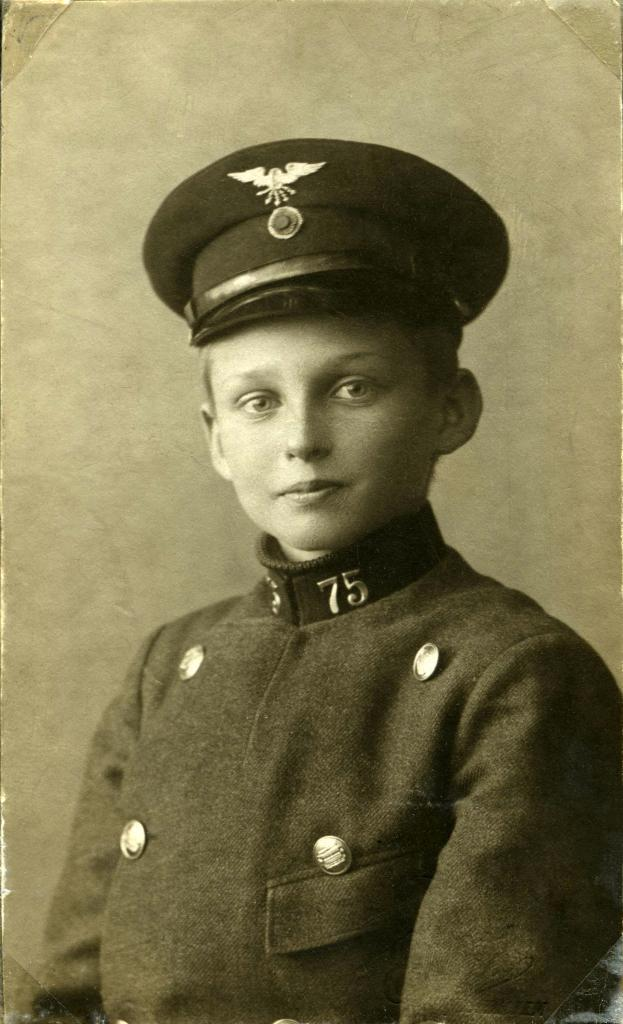Who or what is present in the image? There is a person in the image. What is the person wearing on their head? The person is wearing a cap. Can you describe the cap further? There is an emblem on the cap. What can be seen in the background of the image? There is a wall in the background of the image. What type of yam is being ordered by the person in the image? There is no yam or any indication of ordering food in the image. 